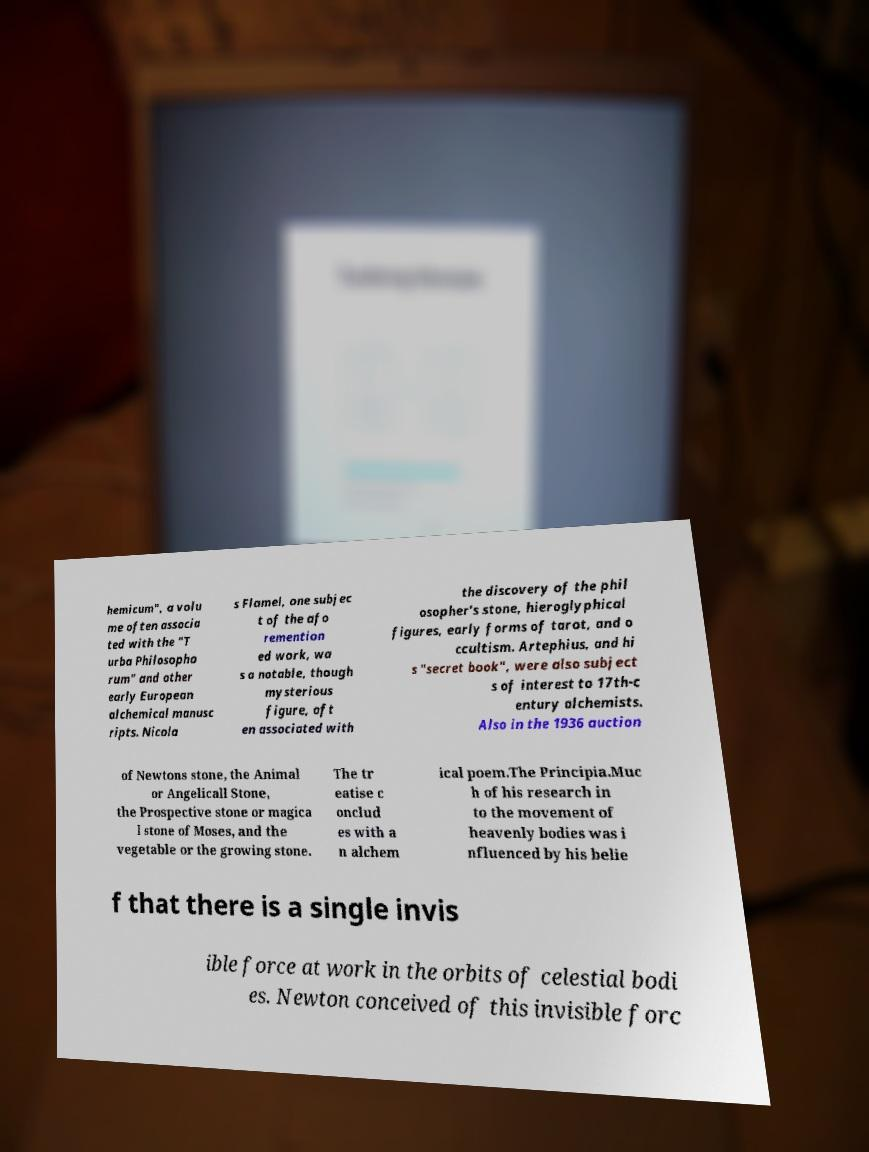Can you read and provide the text displayed in the image?This photo seems to have some interesting text. Can you extract and type it out for me? hemicum", a volu me often associa ted with the "T urba Philosopho rum" and other early European alchemical manusc ripts. Nicola s Flamel, one subjec t of the afo remention ed work, wa s a notable, though mysterious figure, oft en associated with the discovery of the phil osopher's stone, hieroglyphical figures, early forms of tarot, and o ccultism. Artephius, and hi s "secret book", were also subject s of interest to 17th-c entury alchemists. Also in the 1936 auction of Newtons stone, the Animal or Angelicall Stone, the Prospective stone or magica l stone of Moses, and the vegetable or the growing stone. The tr eatise c onclud es with a n alchem ical poem.The Principia.Muc h of his research in to the movement of heavenly bodies was i nfluenced by his belie f that there is a single invis ible force at work in the orbits of celestial bodi es. Newton conceived of this invisible forc 